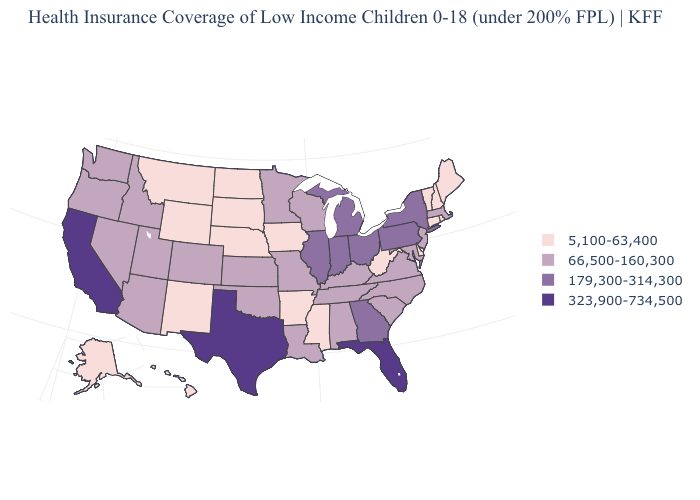Does South Dakota have the same value as California?
Keep it brief. No. Name the states that have a value in the range 66,500-160,300?
Give a very brief answer. Alabama, Arizona, Colorado, Idaho, Kansas, Kentucky, Louisiana, Maryland, Massachusetts, Minnesota, Missouri, Nevada, New Jersey, North Carolina, Oklahoma, Oregon, South Carolina, Tennessee, Utah, Virginia, Washington, Wisconsin. Does the map have missing data?
Short answer required. No. Which states hav the highest value in the Northeast?
Answer briefly. New York, Pennsylvania. Which states have the lowest value in the Northeast?
Answer briefly. Connecticut, Maine, New Hampshire, Rhode Island, Vermont. Among the states that border Utah , which have the lowest value?
Short answer required. New Mexico, Wyoming. What is the value of Idaho?
Concise answer only. 66,500-160,300. Name the states that have a value in the range 179,300-314,300?
Write a very short answer. Georgia, Illinois, Indiana, Michigan, New York, Ohio, Pennsylvania. Which states have the highest value in the USA?
Quick response, please. California, Florida, Texas. Which states have the lowest value in the MidWest?
Write a very short answer. Iowa, Nebraska, North Dakota, South Dakota. Is the legend a continuous bar?
Short answer required. No. What is the value of South Dakota?
Concise answer only. 5,100-63,400. Name the states that have a value in the range 323,900-734,500?
Keep it brief. California, Florida, Texas. What is the value of Massachusetts?
Concise answer only. 66,500-160,300. What is the value of Oregon?
Be succinct. 66,500-160,300. 